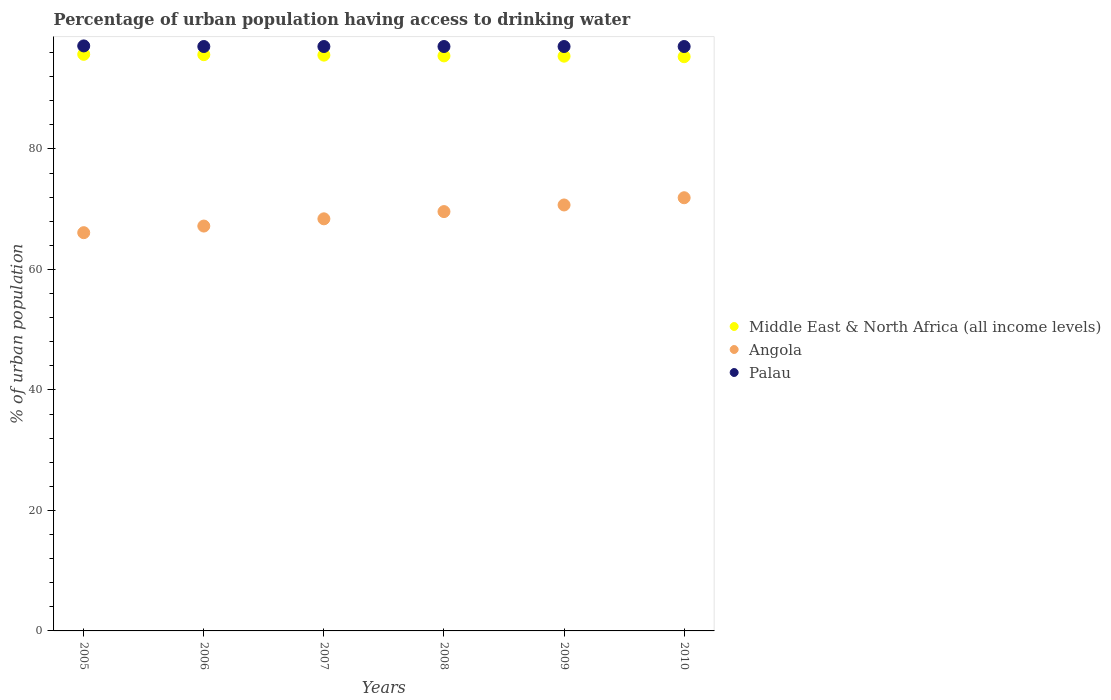Is the number of dotlines equal to the number of legend labels?
Your answer should be very brief. Yes. What is the percentage of urban population having access to drinking water in Angola in 2005?
Provide a short and direct response. 66.1. Across all years, what is the maximum percentage of urban population having access to drinking water in Angola?
Offer a terse response. 71.9. Across all years, what is the minimum percentage of urban population having access to drinking water in Middle East & North Africa (all income levels)?
Your answer should be very brief. 95.31. What is the total percentage of urban population having access to drinking water in Angola in the graph?
Offer a terse response. 413.9. What is the difference between the percentage of urban population having access to drinking water in Middle East & North Africa (all income levels) in 2006 and that in 2010?
Ensure brevity in your answer.  0.34. What is the difference between the percentage of urban population having access to drinking water in Angola in 2006 and the percentage of urban population having access to drinking water in Palau in 2009?
Your response must be concise. -29.8. What is the average percentage of urban population having access to drinking water in Angola per year?
Your response must be concise. 68.98. In the year 2006, what is the difference between the percentage of urban population having access to drinking water in Middle East & North Africa (all income levels) and percentage of urban population having access to drinking water in Palau?
Your response must be concise. -1.35. In how many years, is the percentage of urban population having access to drinking water in Palau greater than 12 %?
Provide a short and direct response. 6. What is the ratio of the percentage of urban population having access to drinking water in Angola in 2009 to that in 2010?
Make the answer very short. 0.98. What is the difference between the highest and the second highest percentage of urban population having access to drinking water in Palau?
Offer a terse response. 0.1. What is the difference between the highest and the lowest percentage of urban population having access to drinking water in Middle East & North Africa (all income levels)?
Give a very brief answer. 0.39. In how many years, is the percentage of urban population having access to drinking water in Angola greater than the average percentage of urban population having access to drinking water in Angola taken over all years?
Ensure brevity in your answer.  3. Is the sum of the percentage of urban population having access to drinking water in Angola in 2008 and 2009 greater than the maximum percentage of urban population having access to drinking water in Middle East & North Africa (all income levels) across all years?
Ensure brevity in your answer.  Yes. Is it the case that in every year, the sum of the percentage of urban population having access to drinking water in Angola and percentage of urban population having access to drinking water in Palau  is greater than the percentage of urban population having access to drinking water in Middle East & North Africa (all income levels)?
Your answer should be compact. Yes. Does the percentage of urban population having access to drinking water in Middle East & North Africa (all income levels) monotonically increase over the years?
Give a very brief answer. No. Is the percentage of urban population having access to drinking water in Middle East & North Africa (all income levels) strictly greater than the percentage of urban population having access to drinking water in Angola over the years?
Ensure brevity in your answer.  Yes. How many dotlines are there?
Make the answer very short. 3. How many years are there in the graph?
Give a very brief answer. 6. Does the graph contain grids?
Ensure brevity in your answer.  No. Where does the legend appear in the graph?
Give a very brief answer. Center right. How many legend labels are there?
Provide a succinct answer. 3. How are the legend labels stacked?
Ensure brevity in your answer.  Vertical. What is the title of the graph?
Offer a very short reply. Percentage of urban population having access to drinking water. Does "Middle East & North Africa (developing only)" appear as one of the legend labels in the graph?
Provide a succinct answer. No. What is the label or title of the X-axis?
Keep it short and to the point. Years. What is the label or title of the Y-axis?
Ensure brevity in your answer.  % of urban population. What is the % of urban population in Middle East & North Africa (all income levels) in 2005?
Offer a very short reply. 95.7. What is the % of urban population of Angola in 2005?
Offer a terse response. 66.1. What is the % of urban population of Palau in 2005?
Make the answer very short. 97.1. What is the % of urban population in Middle East & North Africa (all income levels) in 2006?
Your response must be concise. 95.65. What is the % of urban population in Angola in 2006?
Offer a very short reply. 67.2. What is the % of urban population in Palau in 2006?
Ensure brevity in your answer.  97. What is the % of urban population in Middle East & North Africa (all income levels) in 2007?
Provide a succinct answer. 95.57. What is the % of urban population in Angola in 2007?
Make the answer very short. 68.4. What is the % of urban population of Palau in 2007?
Provide a short and direct response. 97. What is the % of urban population in Middle East & North Africa (all income levels) in 2008?
Offer a very short reply. 95.45. What is the % of urban population in Angola in 2008?
Your response must be concise. 69.6. What is the % of urban population in Palau in 2008?
Provide a short and direct response. 97. What is the % of urban population in Middle East & North Africa (all income levels) in 2009?
Your answer should be very brief. 95.4. What is the % of urban population of Angola in 2009?
Offer a terse response. 70.7. What is the % of urban population in Palau in 2009?
Make the answer very short. 97. What is the % of urban population in Middle East & North Africa (all income levels) in 2010?
Ensure brevity in your answer.  95.31. What is the % of urban population of Angola in 2010?
Offer a very short reply. 71.9. What is the % of urban population in Palau in 2010?
Offer a very short reply. 97. Across all years, what is the maximum % of urban population of Middle East & North Africa (all income levels)?
Provide a short and direct response. 95.7. Across all years, what is the maximum % of urban population of Angola?
Give a very brief answer. 71.9. Across all years, what is the maximum % of urban population in Palau?
Provide a succinct answer. 97.1. Across all years, what is the minimum % of urban population of Middle East & North Africa (all income levels)?
Provide a short and direct response. 95.31. Across all years, what is the minimum % of urban population in Angola?
Offer a terse response. 66.1. Across all years, what is the minimum % of urban population of Palau?
Provide a succinct answer. 97. What is the total % of urban population of Middle East & North Africa (all income levels) in the graph?
Provide a short and direct response. 573.07. What is the total % of urban population in Angola in the graph?
Make the answer very short. 413.9. What is the total % of urban population of Palau in the graph?
Keep it short and to the point. 582.1. What is the difference between the % of urban population in Middle East & North Africa (all income levels) in 2005 and that in 2006?
Make the answer very short. 0.06. What is the difference between the % of urban population of Angola in 2005 and that in 2006?
Offer a very short reply. -1.1. What is the difference between the % of urban population in Palau in 2005 and that in 2006?
Make the answer very short. 0.1. What is the difference between the % of urban population of Middle East & North Africa (all income levels) in 2005 and that in 2007?
Offer a terse response. 0.14. What is the difference between the % of urban population in Middle East & North Africa (all income levels) in 2005 and that in 2008?
Make the answer very short. 0.26. What is the difference between the % of urban population in Palau in 2005 and that in 2008?
Offer a terse response. 0.1. What is the difference between the % of urban population in Middle East & North Africa (all income levels) in 2005 and that in 2009?
Offer a terse response. 0.31. What is the difference between the % of urban population of Middle East & North Africa (all income levels) in 2005 and that in 2010?
Provide a succinct answer. 0.39. What is the difference between the % of urban population of Angola in 2005 and that in 2010?
Give a very brief answer. -5.8. What is the difference between the % of urban population of Middle East & North Africa (all income levels) in 2006 and that in 2007?
Your answer should be compact. 0.08. What is the difference between the % of urban population in Middle East & North Africa (all income levels) in 2006 and that in 2008?
Your response must be concise. 0.2. What is the difference between the % of urban population in Angola in 2006 and that in 2008?
Your answer should be very brief. -2.4. What is the difference between the % of urban population in Palau in 2006 and that in 2008?
Offer a very short reply. 0. What is the difference between the % of urban population of Middle East & North Africa (all income levels) in 2006 and that in 2009?
Offer a very short reply. 0.25. What is the difference between the % of urban population in Middle East & North Africa (all income levels) in 2006 and that in 2010?
Offer a terse response. 0.34. What is the difference between the % of urban population of Palau in 2006 and that in 2010?
Your response must be concise. 0. What is the difference between the % of urban population of Middle East & North Africa (all income levels) in 2007 and that in 2008?
Offer a terse response. 0.12. What is the difference between the % of urban population of Angola in 2007 and that in 2008?
Make the answer very short. -1.2. What is the difference between the % of urban population of Middle East & North Africa (all income levels) in 2007 and that in 2009?
Offer a terse response. 0.17. What is the difference between the % of urban population of Angola in 2007 and that in 2009?
Ensure brevity in your answer.  -2.3. What is the difference between the % of urban population in Palau in 2007 and that in 2009?
Your answer should be very brief. 0. What is the difference between the % of urban population in Middle East & North Africa (all income levels) in 2007 and that in 2010?
Your answer should be very brief. 0.26. What is the difference between the % of urban population in Angola in 2007 and that in 2010?
Provide a short and direct response. -3.5. What is the difference between the % of urban population of Middle East & North Africa (all income levels) in 2008 and that in 2009?
Provide a succinct answer. 0.05. What is the difference between the % of urban population in Palau in 2008 and that in 2009?
Offer a terse response. 0. What is the difference between the % of urban population of Middle East & North Africa (all income levels) in 2008 and that in 2010?
Provide a short and direct response. 0.14. What is the difference between the % of urban population of Angola in 2008 and that in 2010?
Ensure brevity in your answer.  -2.3. What is the difference between the % of urban population of Palau in 2008 and that in 2010?
Keep it short and to the point. 0. What is the difference between the % of urban population of Middle East & North Africa (all income levels) in 2009 and that in 2010?
Your answer should be compact. 0.09. What is the difference between the % of urban population of Palau in 2009 and that in 2010?
Keep it short and to the point. 0. What is the difference between the % of urban population in Middle East & North Africa (all income levels) in 2005 and the % of urban population in Angola in 2006?
Provide a short and direct response. 28.5. What is the difference between the % of urban population of Middle East & North Africa (all income levels) in 2005 and the % of urban population of Palau in 2006?
Make the answer very short. -1.3. What is the difference between the % of urban population in Angola in 2005 and the % of urban population in Palau in 2006?
Provide a succinct answer. -30.9. What is the difference between the % of urban population of Middle East & North Africa (all income levels) in 2005 and the % of urban population of Angola in 2007?
Make the answer very short. 27.3. What is the difference between the % of urban population in Middle East & North Africa (all income levels) in 2005 and the % of urban population in Palau in 2007?
Make the answer very short. -1.3. What is the difference between the % of urban population in Angola in 2005 and the % of urban population in Palau in 2007?
Ensure brevity in your answer.  -30.9. What is the difference between the % of urban population of Middle East & North Africa (all income levels) in 2005 and the % of urban population of Angola in 2008?
Provide a succinct answer. 26.1. What is the difference between the % of urban population in Middle East & North Africa (all income levels) in 2005 and the % of urban population in Palau in 2008?
Your response must be concise. -1.3. What is the difference between the % of urban population of Angola in 2005 and the % of urban population of Palau in 2008?
Your answer should be compact. -30.9. What is the difference between the % of urban population of Middle East & North Africa (all income levels) in 2005 and the % of urban population of Angola in 2009?
Ensure brevity in your answer.  25. What is the difference between the % of urban population of Middle East & North Africa (all income levels) in 2005 and the % of urban population of Palau in 2009?
Your answer should be very brief. -1.3. What is the difference between the % of urban population of Angola in 2005 and the % of urban population of Palau in 2009?
Provide a succinct answer. -30.9. What is the difference between the % of urban population in Middle East & North Africa (all income levels) in 2005 and the % of urban population in Angola in 2010?
Make the answer very short. 23.8. What is the difference between the % of urban population of Middle East & North Africa (all income levels) in 2005 and the % of urban population of Palau in 2010?
Your response must be concise. -1.3. What is the difference between the % of urban population of Angola in 2005 and the % of urban population of Palau in 2010?
Give a very brief answer. -30.9. What is the difference between the % of urban population in Middle East & North Africa (all income levels) in 2006 and the % of urban population in Angola in 2007?
Your response must be concise. 27.25. What is the difference between the % of urban population of Middle East & North Africa (all income levels) in 2006 and the % of urban population of Palau in 2007?
Keep it short and to the point. -1.35. What is the difference between the % of urban population in Angola in 2006 and the % of urban population in Palau in 2007?
Your answer should be very brief. -29.8. What is the difference between the % of urban population of Middle East & North Africa (all income levels) in 2006 and the % of urban population of Angola in 2008?
Offer a very short reply. 26.05. What is the difference between the % of urban population in Middle East & North Africa (all income levels) in 2006 and the % of urban population in Palau in 2008?
Provide a succinct answer. -1.35. What is the difference between the % of urban population of Angola in 2006 and the % of urban population of Palau in 2008?
Provide a succinct answer. -29.8. What is the difference between the % of urban population of Middle East & North Africa (all income levels) in 2006 and the % of urban population of Angola in 2009?
Ensure brevity in your answer.  24.95. What is the difference between the % of urban population of Middle East & North Africa (all income levels) in 2006 and the % of urban population of Palau in 2009?
Make the answer very short. -1.35. What is the difference between the % of urban population in Angola in 2006 and the % of urban population in Palau in 2009?
Ensure brevity in your answer.  -29.8. What is the difference between the % of urban population of Middle East & North Africa (all income levels) in 2006 and the % of urban population of Angola in 2010?
Your answer should be compact. 23.75. What is the difference between the % of urban population in Middle East & North Africa (all income levels) in 2006 and the % of urban population in Palau in 2010?
Your response must be concise. -1.35. What is the difference between the % of urban population of Angola in 2006 and the % of urban population of Palau in 2010?
Keep it short and to the point. -29.8. What is the difference between the % of urban population in Middle East & North Africa (all income levels) in 2007 and the % of urban population in Angola in 2008?
Offer a very short reply. 25.97. What is the difference between the % of urban population of Middle East & North Africa (all income levels) in 2007 and the % of urban population of Palau in 2008?
Your answer should be very brief. -1.43. What is the difference between the % of urban population in Angola in 2007 and the % of urban population in Palau in 2008?
Ensure brevity in your answer.  -28.6. What is the difference between the % of urban population of Middle East & North Africa (all income levels) in 2007 and the % of urban population of Angola in 2009?
Provide a succinct answer. 24.87. What is the difference between the % of urban population in Middle East & North Africa (all income levels) in 2007 and the % of urban population in Palau in 2009?
Your answer should be compact. -1.43. What is the difference between the % of urban population of Angola in 2007 and the % of urban population of Palau in 2009?
Your answer should be compact. -28.6. What is the difference between the % of urban population in Middle East & North Africa (all income levels) in 2007 and the % of urban population in Angola in 2010?
Offer a terse response. 23.67. What is the difference between the % of urban population of Middle East & North Africa (all income levels) in 2007 and the % of urban population of Palau in 2010?
Ensure brevity in your answer.  -1.43. What is the difference between the % of urban population of Angola in 2007 and the % of urban population of Palau in 2010?
Keep it short and to the point. -28.6. What is the difference between the % of urban population of Middle East & North Africa (all income levels) in 2008 and the % of urban population of Angola in 2009?
Your answer should be very brief. 24.75. What is the difference between the % of urban population in Middle East & North Africa (all income levels) in 2008 and the % of urban population in Palau in 2009?
Your answer should be compact. -1.55. What is the difference between the % of urban population of Angola in 2008 and the % of urban population of Palau in 2009?
Provide a short and direct response. -27.4. What is the difference between the % of urban population in Middle East & North Africa (all income levels) in 2008 and the % of urban population in Angola in 2010?
Offer a terse response. 23.55. What is the difference between the % of urban population in Middle East & North Africa (all income levels) in 2008 and the % of urban population in Palau in 2010?
Your response must be concise. -1.55. What is the difference between the % of urban population of Angola in 2008 and the % of urban population of Palau in 2010?
Your answer should be compact. -27.4. What is the difference between the % of urban population in Middle East & North Africa (all income levels) in 2009 and the % of urban population in Angola in 2010?
Keep it short and to the point. 23.5. What is the difference between the % of urban population in Middle East & North Africa (all income levels) in 2009 and the % of urban population in Palau in 2010?
Provide a succinct answer. -1.6. What is the difference between the % of urban population of Angola in 2009 and the % of urban population of Palau in 2010?
Your answer should be compact. -26.3. What is the average % of urban population of Middle East & North Africa (all income levels) per year?
Your response must be concise. 95.51. What is the average % of urban population of Angola per year?
Your response must be concise. 68.98. What is the average % of urban population in Palau per year?
Ensure brevity in your answer.  97.02. In the year 2005, what is the difference between the % of urban population of Middle East & North Africa (all income levels) and % of urban population of Angola?
Provide a short and direct response. 29.6. In the year 2005, what is the difference between the % of urban population of Middle East & North Africa (all income levels) and % of urban population of Palau?
Keep it short and to the point. -1.4. In the year 2005, what is the difference between the % of urban population of Angola and % of urban population of Palau?
Provide a succinct answer. -31. In the year 2006, what is the difference between the % of urban population of Middle East & North Africa (all income levels) and % of urban population of Angola?
Make the answer very short. 28.45. In the year 2006, what is the difference between the % of urban population of Middle East & North Africa (all income levels) and % of urban population of Palau?
Provide a short and direct response. -1.35. In the year 2006, what is the difference between the % of urban population of Angola and % of urban population of Palau?
Offer a terse response. -29.8. In the year 2007, what is the difference between the % of urban population in Middle East & North Africa (all income levels) and % of urban population in Angola?
Your answer should be compact. 27.17. In the year 2007, what is the difference between the % of urban population in Middle East & North Africa (all income levels) and % of urban population in Palau?
Ensure brevity in your answer.  -1.43. In the year 2007, what is the difference between the % of urban population in Angola and % of urban population in Palau?
Your response must be concise. -28.6. In the year 2008, what is the difference between the % of urban population in Middle East & North Africa (all income levels) and % of urban population in Angola?
Provide a short and direct response. 25.85. In the year 2008, what is the difference between the % of urban population of Middle East & North Africa (all income levels) and % of urban population of Palau?
Give a very brief answer. -1.55. In the year 2008, what is the difference between the % of urban population in Angola and % of urban population in Palau?
Provide a short and direct response. -27.4. In the year 2009, what is the difference between the % of urban population of Middle East & North Africa (all income levels) and % of urban population of Angola?
Provide a short and direct response. 24.7. In the year 2009, what is the difference between the % of urban population of Middle East & North Africa (all income levels) and % of urban population of Palau?
Provide a succinct answer. -1.6. In the year 2009, what is the difference between the % of urban population in Angola and % of urban population in Palau?
Make the answer very short. -26.3. In the year 2010, what is the difference between the % of urban population of Middle East & North Africa (all income levels) and % of urban population of Angola?
Offer a very short reply. 23.41. In the year 2010, what is the difference between the % of urban population in Middle East & North Africa (all income levels) and % of urban population in Palau?
Your response must be concise. -1.69. In the year 2010, what is the difference between the % of urban population of Angola and % of urban population of Palau?
Offer a terse response. -25.1. What is the ratio of the % of urban population of Middle East & North Africa (all income levels) in 2005 to that in 2006?
Your response must be concise. 1. What is the ratio of the % of urban population in Angola in 2005 to that in 2006?
Make the answer very short. 0.98. What is the ratio of the % of urban population of Palau in 2005 to that in 2006?
Your answer should be very brief. 1. What is the ratio of the % of urban population of Middle East & North Africa (all income levels) in 2005 to that in 2007?
Ensure brevity in your answer.  1. What is the ratio of the % of urban population in Angola in 2005 to that in 2007?
Offer a very short reply. 0.97. What is the ratio of the % of urban population of Middle East & North Africa (all income levels) in 2005 to that in 2008?
Your answer should be compact. 1. What is the ratio of the % of urban population of Angola in 2005 to that in 2008?
Provide a succinct answer. 0.95. What is the ratio of the % of urban population in Palau in 2005 to that in 2008?
Provide a succinct answer. 1. What is the ratio of the % of urban population in Angola in 2005 to that in 2009?
Provide a short and direct response. 0.93. What is the ratio of the % of urban population of Angola in 2005 to that in 2010?
Make the answer very short. 0.92. What is the ratio of the % of urban population in Middle East & North Africa (all income levels) in 2006 to that in 2007?
Offer a terse response. 1. What is the ratio of the % of urban population of Angola in 2006 to that in 2007?
Provide a succinct answer. 0.98. What is the ratio of the % of urban population in Angola in 2006 to that in 2008?
Your answer should be compact. 0.97. What is the ratio of the % of urban population of Palau in 2006 to that in 2008?
Offer a very short reply. 1. What is the ratio of the % of urban population of Middle East & North Africa (all income levels) in 2006 to that in 2009?
Give a very brief answer. 1. What is the ratio of the % of urban population of Angola in 2006 to that in 2009?
Provide a short and direct response. 0.95. What is the ratio of the % of urban population of Angola in 2006 to that in 2010?
Provide a succinct answer. 0.93. What is the ratio of the % of urban population in Palau in 2006 to that in 2010?
Your response must be concise. 1. What is the ratio of the % of urban population in Middle East & North Africa (all income levels) in 2007 to that in 2008?
Your answer should be compact. 1. What is the ratio of the % of urban population of Angola in 2007 to that in 2008?
Offer a very short reply. 0.98. What is the ratio of the % of urban population in Palau in 2007 to that in 2008?
Provide a short and direct response. 1. What is the ratio of the % of urban population of Middle East & North Africa (all income levels) in 2007 to that in 2009?
Offer a very short reply. 1. What is the ratio of the % of urban population of Angola in 2007 to that in 2009?
Make the answer very short. 0.97. What is the ratio of the % of urban population in Palau in 2007 to that in 2009?
Your answer should be very brief. 1. What is the ratio of the % of urban population of Angola in 2007 to that in 2010?
Provide a short and direct response. 0.95. What is the ratio of the % of urban population in Palau in 2007 to that in 2010?
Offer a very short reply. 1. What is the ratio of the % of urban population in Middle East & North Africa (all income levels) in 2008 to that in 2009?
Provide a short and direct response. 1. What is the ratio of the % of urban population in Angola in 2008 to that in 2009?
Provide a short and direct response. 0.98. What is the ratio of the % of urban population in Palau in 2008 to that in 2010?
Offer a terse response. 1. What is the ratio of the % of urban population in Middle East & North Africa (all income levels) in 2009 to that in 2010?
Ensure brevity in your answer.  1. What is the ratio of the % of urban population of Angola in 2009 to that in 2010?
Offer a very short reply. 0.98. What is the ratio of the % of urban population in Palau in 2009 to that in 2010?
Provide a short and direct response. 1. What is the difference between the highest and the second highest % of urban population of Middle East & North Africa (all income levels)?
Keep it short and to the point. 0.06. What is the difference between the highest and the lowest % of urban population in Middle East & North Africa (all income levels)?
Your answer should be very brief. 0.39. What is the difference between the highest and the lowest % of urban population in Angola?
Provide a succinct answer. 5.8. 